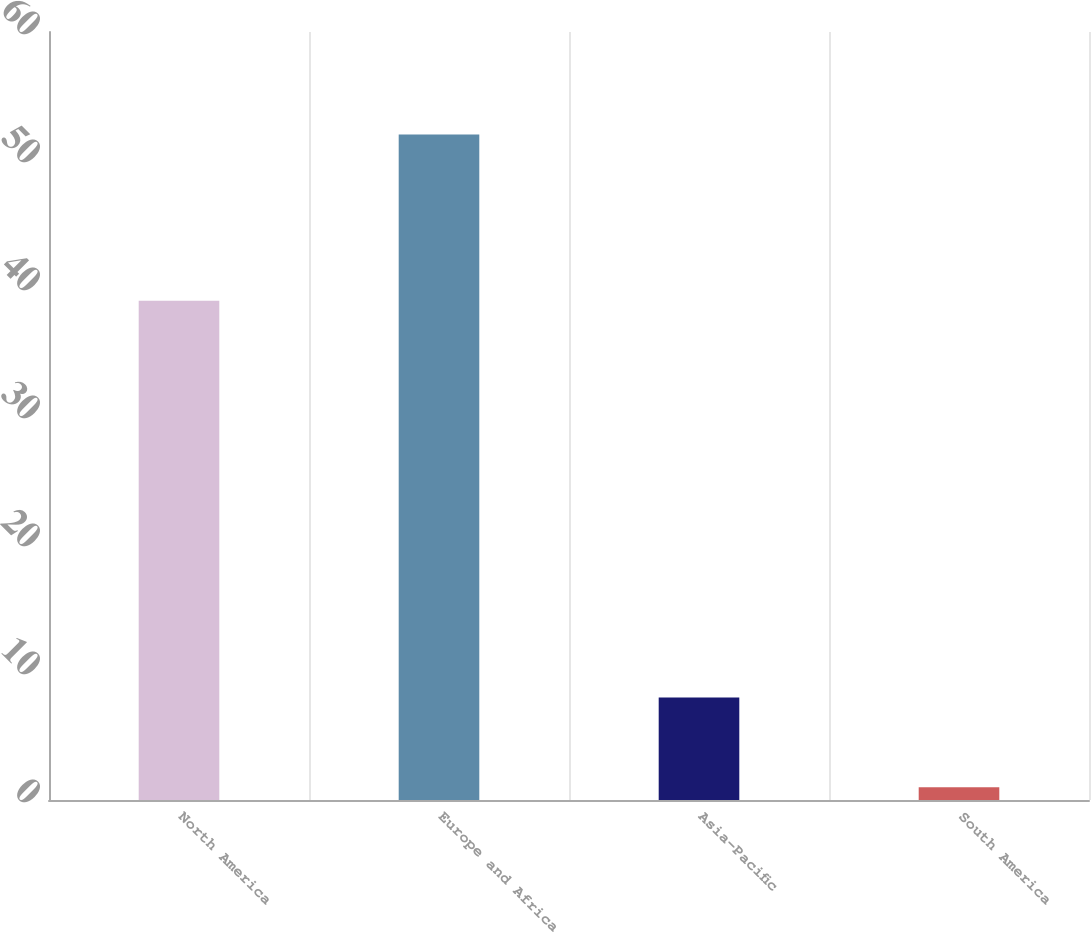<chart> <loc_0><loc_0><loc_500><loc_500><bar_chart><fcel>North America<fcel>Europe and Africa<fcel>Asia-Pacific<fcel>South America<nl><fcel>39<fcel>52<fcel>8<fcel>1<nl></chart> 